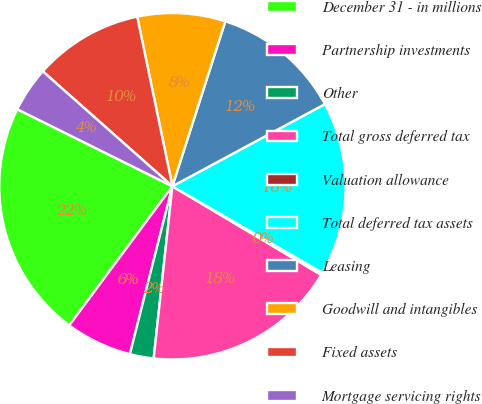<chart> <loc_0><loc_0><loc_500><loc_500><pie_chart><fcel>December 31 - in millions<fcel>Partnership investments<fcel>Other<fcel>Total gross deferred tax<fcel>Valuation allowance<fcel>Total deferred tax assets<fcel>Leasing<fcel>Goodwill and intangibles<fcel>Fixed assets<fcel>Mortgage servicing rights<nl><fcel>22.18%<fcel>6.21%<fcel>2.22%<fcel>18.18%<fcel>0.22%<fcel>16.19%<fcel>12.2%<fcel>8.2%<fcel>10.2%<fcel>4.21%<nl></chart> 